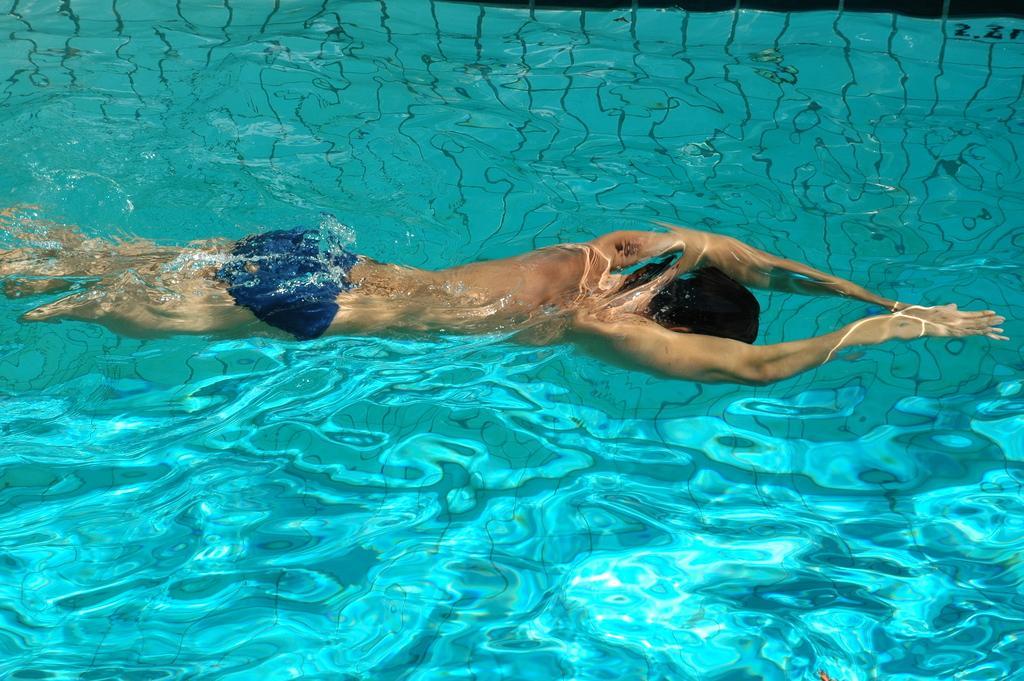In one or two sentences, can you explain what this image depicts? In this image there is a person swimming in the water. 